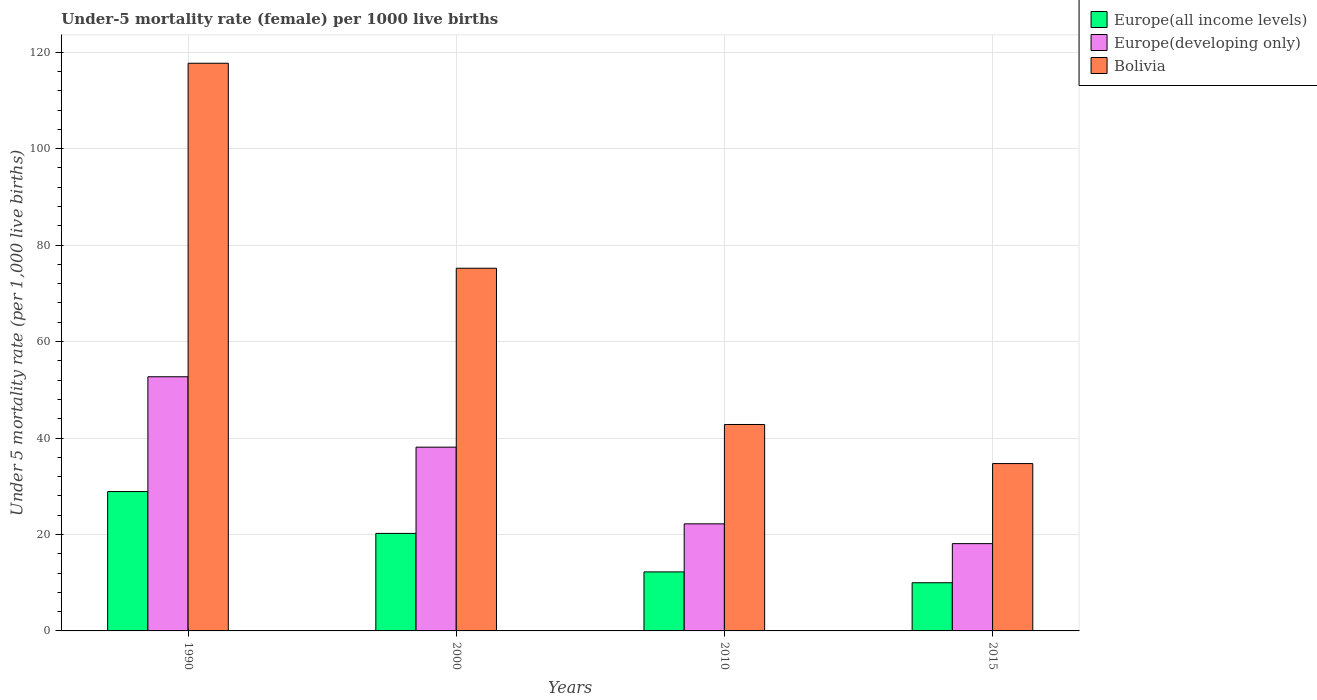How many different coloured bars are there?
Make the answer very short. 3. How many groups of bars are there?
Your answer should be compact. 4. Are the number of bars per tick equal to the number of legend labels?
Your answer should be compact. Yes. Are the number of bars on each tick of the X-axis equal?
Make the answer very short. Yes. What is the label of the 4th group of bars from the left?
Offer a terse response. 2015. What is the under-five mortality rate in Bolivia in 2015?
Provide a succinct answer. 34.7. Across all years, what is the maximum under-five mortality rate in Europe(all income levels)?
Your answer should be very brief. 28.9. Across all years, what is the minimum under-five mortality rate in Europe(developing only)?
Provide a succinct answer. 18.1. In which year was the under-five mortality rate in Europe(all income levels) minimum?
Your answer should be very brief. 2015. What is the total under-five mortality rate in Europe(developing only) in the graph?
Keep it short and to the point. 131.1. What is the difference between the under-five mortality rate in Europe(all income levels) in 2010 and that in 2015?
Offer a very short reply. 2.25. What is the difference between the under-five mortality rate in Europe(all income levels) in 2015 and the under-five mortality rate in Bolivia in 1990?
Offer a terse response. -107.71. What is the average under-five mortality rate in Europe(all income levels) per year?
Give a very brief answer. 17.84. In the year 2000, what is the difference between the under-five mortality rate in Europe(developing only) and under-five mortality rate in Europe(all income levels)?
Give a very brief answer. 17.88. What is the ratio of the under-five mortality rate in Europe(developing only) in 1990 to that in 2015?
Keep it short and to the point. 2.91. Is the under-five mortality rate in Europe(developing only) in 2000 less than that in 2015?
Offer a very short reply. No. What is the difference between the highest and the second highest under-five mortality rate in Europe(all income levels)?
Provide a succinct answer. 8.68. What is the difference between the highest and the lowest under-five mortality rate in Europe(all income levels)?
Your response must be concise. 18.9. Is the sum of the under-five mortality rate in Bolivia in 1990 and 2010 greater than the maximum under-five mortality rate in Europe(all income levels) across all years?
Offer a very short reply. Yes. What does the 1st bar from the left in 2015 represents?
Offer a terse response. Europe(all income levels). What does the 1st bar from the right in 2010 represents?
Keep it short and to the point. Bolivia. How many bars are there?
Provide a succinct answer. 12. How many years are there in the graph?
Ensure brevity in your answer.  4. What is the difference between two consecutive major ticks on the Y-axis?
Provide a short and direct response. 20. Are the values on the major ticks of Y-axis written in scientific E-notation?
Provide a succinct answer. No. Does the graph contain any zero values?
Offer a terse response. No. Where does the legend appear in the graph?
Give a very brief answer. Top right. How many legend labels are there?
Keep it short and to the point. 3. How are the legend labels stacked?
Make the answer very short. Vertical. What is the title of the graph?
Provide a succinct answer. Under-5 mortality rate (female) per 1000 live births. Does "Madagascar" appear as one of the legend labels in the graph?
Your answer should be compact. No. What is the label or title of the X-axis?
Your answer should be compact. Years. What is the label or title of the Y-axis?
Offer a very short reply. Under 5 mortality rate (per 1,0 live births). What is the Under 5 mortality rate (per 1,000 live births) of Europe(all income levels) in 1990?
Provide a short and direct response. 28.9. What is the Under 5 mortality rate (per 1,000 live births) of Europe(developing only) in 1990?
Offer a very short reply. 52.7. What is the Under 5 mortality rate (per 1,000 live births) in Bolivia in 1990?
Your answer should be compact. 117.7. What is the Under 5 mortality rate (per 1,000 live births) of Europe(all income levels) in 2000?
Give a very brief answer. 20.22. What is the Under 5 mortality rate (per 1,000 live births) in Europe(developing only) in 2000?
Ensure brevity in your answer.  38.1. What is the Under 5 mortality rate (per 1,000 live births) of Bolivia in 2000?
Ensure brevity in your answer.  75.2. What is the Under 5 mortality rate (per 1,000 live births) of Europe(all income levels) in 2010?
Make the answer very short. 12.24. What is the Under 5 mortality rate (per 1,000 live births) in Bolivia in 2010?
Your answer should be very brief. 42.8. What is the Under 5 mortality rate (per 1,000 live births) in Europe(all income levels) in 2015?
Provide a succinct answer. 9.99. What is the Under 5 mortality rate (per 1,000 live births) in Europe(developing only) in 2015?
Provide a succinct answer. 18.1. What is the Under 5 mortality rate (per 1,000 live births) in Bolivia in 2015?
Your response must be concise. 34.7. Across all years, what is the maximum Under 5 mortality rate (per 1,000 live births) of Europe(all income levels)?
Offer a very short reply. 28.9. Across all years, what is the maximum Under 5 mortality rate (per 1,000 live births) of Europe(developing only)?
Offer a terse response. 52.7. Across all years, what is the maximum Under 5 mortality rate (per 1,000 live births) in Bolivia?
Offer a very short reply. 117.7. Across all years, what is the minimum Under 5 mortality rate (per 1,000 live births) of Europe(all income levels)?
Ensure brevity in your answer.  9.99. Across all years, what is the minimum Under 5 mortality rate (per 1,000 live births) in Europe(developing only)?
Keep it short and to the point. 18.1. Across all years, what is the minimum Under 5 mortality rate (per 1,000 live births) of Bolivia?
Give a very brief answer. 34.7. What is the total Under 5 mortality rate (per 1,000 live births) of Europe(all income levels) in the graph?
Your answer should be compact. 71.34. What is the total Under 5 mortality rate (per 1,000 live births) of Europe(developing only) in the graph?
Provide a succinct answer. 131.1. What is the total Under 5 mortality rate (per 1,000 live births) in Bolivia in the graph?
Ensure brevity in your answer.  270.4. What is the difference between the Under 5 mortality rate (per 1,000 live births) of Europe(all income levels) in 1990 and that in 2000?
Provide a succinct answer. 8.68. What is the difference between the Under 5 mortality rate (per 1,000 live births) in Bolivia in 1990 and that in 2000?
Offer a terse response. 42.5. What is the difference between the Under 5 mortality rate (per 1,000 live births) in Europe(all income levels) in 1990 and that in 2010?
Keep it short and to the point. 16.66. What is the difference between the Under 5 mortality rate (per 1,000 live births) of Europe(developing only) in 1990 and that in 2010?
Keep it short and to the point. 30.5. What is the difference between the Under 5 mortality rate (per 1,000 live births) of Bolivia in 1990 and that in 2010?
Give a very brief answer. 74.9. What is the difference between the Under 5 mortality rate (per 1,000 live births) in Europe(all income levels) in 1990 and that in 2015?
Your response must be concise. 18.9. What is the difference between the Under 5 mortality rate (per 1,000 live births) of Europe(developing only) in 1990 and that in 2015?
Offer a terse response. 34.6. What is the difference between the Under 5 mortality rate (per 1,000 live births) of Europe(all income levels) in 2000 and that in 2010?
Make the answer very short. 7.98. What is the difference between the Under 5 mortality rate (per 1,000 live births) of Europe(developing only) in 2000 and that in 2010?
Your answer should be compact. 15.9. What is the difference between the Under 5 mortality rate (per 1,000 live births) in Bolivia in 2000 and that in 2010?
Ensure brevity in your answer.  32.4. What is the difference between the Under 5 mortality rate (per 1,000 live births) of Europe(all income levels) in 2000 and that in 2015?
Offer a terse response. 10.23. What is the difference between the Under 5 mortality rate (per 1,000 live births) in Bolivia in 2000 and that in 2015?
Offer a very short reply. 40.5. What is the difference between the Under 5 mortality rate (per 1,000 live births) in Europe(all income levels) in 2010 and that in 2015?
Your answer should be very brief. 2.25. What is the difference between the Under 5 mortality rate (per 1,000 live births) in Bolivia in 2010 and that in 2015?
Give a very brief answer. 8.1. What is the difference between the Under 5 mortality rate (per 1,000 live births) of Europe(all income levels) in 1990 and the Under 5 mortality rate (per 1,000 live births) of Europe(developing only) in 2000?
Your answer should be very brief. -9.2. What is the difference between the Under 5 mortality rate (per 1,000 live births) of Europe(all income levels) in 1990 and the Under 5 mortality rate (per 1,000 live births) of Bolivia in 2000?
Offer a terse response. -46.3. What is the difference between the Under 5 mortality rate (per 1,000 live births) in Europe(developing only) in 1990 and the Under 5 mortality rate (per 1,000 live births) in Bolivia in 2000?
Make the answer very short. -22.5. What is the difference between the Under 5 mortality rate (per 1,000 live births) of Europe(all income levels) in 1990 and the Under 5 mortality rate (per 1,000 live births) of Europe(developing only) in 2010?
Ensure brevity in your answer.  6.7. What is the difference between the Under 5 mortality rate (per 1,000 live births) in Europe(all income levels) in 1990 and the Under 5 mortality rate (per 1,000 live births) in Bolivia in 2010?
Ensure brevity in your answer.  -13.9. What is the difference between the Under 5 mortality rate (per 1,000 live births) of Europe(all income levels) in 1990 and the Under 5 mortality rate (per 1,000 live births) of Europe(developing only) in 2015?
Make the answer very short. 10.8. What is the difference between the Under 5 mortality rate (per 1,000 live births) in Europe(all income levels) in 1990 and the Under 5 mortality rate (per 1,000 live births) in Bolivia in 2015?
Offer a very short reply. -5.8. What is the difference between the Under 5 mortality rate (per 1,000 live births) of Europe(all income levels) in 2000 and the Under 5 mortality rate (per 1,000 live births) of Europe(developing only) in 2010?
Offer a very short reply. -1.98. What is the difference between the Under 5 mortality rate (per 1,000 live births) of Europe(all income levels) in 2000 and the Under 5 mortality rate (per 1,000 live births) of Bolivia in 2010?
Offer a terse response. -22.58. What is the difference between the Under 5 mortality rate (per 1,000 live births) in Europe(all income levels) in 2000 and the Under 5 mortality rate (per 1,000 live births) in Europe(developing only) in 2015?
Offer a very short reply. 2.12. What is the difference between the Under 5 mortality rate (per 1,000 live births) in Europe(all income levels) in 2000 and the Under 5 mortality rate (per 1,000 live births) in Bolivia in 2015?
Provide a succinct answer. -14.48. What is the difference between the Under 5 mortality rate (per 1,000 live births) of Europe(all income levels) in 2010 and the Under 5 mortality rate (per 1,000 live births) of Europe(developing only) in 2015?
Your response must be concise. -5.86. What is the difference between the Under 5 mortality rate (per 1,000 live births) of Europe(all income levels) in 2010 and the Under 5 mortality rate (per 1,000 live births) of Bolivia in 2015?
Provide a succinct answer. -22.46. What is the average Under 5 mortality rate (per 1,000 live births) of Europe(all income levels) per year?
Offer a terse response. 17.84. What is the average Under 5 mortality rate (per 1,000 live births) of Europe(developing only) per year?
Provide a succinct answer. 32.77. What is the average Under 5 mortality rate (per 1,000 live births) in Bolivia per year?
Offer a very short reply. 67.6. In the year 1990, what is the difference between the Under 5 mortality rate (per 1,000 live births) in Europe(all income levels) and Under 5 mortality rate (per 1,000 live births) in Europe(developing only)?
Keep it short and to the point. -23.8. In the year 1990, what is the difference between the Under 5 mortality rate (per 1,000 live births) of Europe(all income levels) and Under 5 mortality rate (per 1,000 live births) of Bolivia?
Give a very brief answer. -88.8. In the year 1990, what is the difference between the Under 5 mortality rate (per 1,000 live births) in Europe(developing only) and Under 5 mortality rate (per 1,000 live births) in Bolivia?
Provide a short and direct response. -65. In the year 2000, what is the difference between the Under 5 mortality rate (per 1,000 live births) of Europe(all income levels) and Under 5 mortality rate (per 1,000 live births) of Europe(developing only)?
Your response must be concise. -17.88. In the year 2000, what is the difference between the Under 5 mortality rate (per 1,000 live births) in Europe(all income levels) and Under 5 mortality rate (per 1,000 live births) in Bolivia?
Provide a succinct answer. -54.98. In the year 2000, what is the difference between the Under 5 mortality rate (per 1,000 live births) in Europe(developing only) and Under 5 mortality rate (per 1,000 live births) in Bolivia?
Keep it short and to the point. -37.1. In the year 2010, what is the difference between the Under 5 mortality rate (per 1,000 live births) of Europe(all income levels) and Under 5 mortality rate (per 1,000 live births) of Europe(developing only)?
Your answer should be compact. -9.96. In the year 2010, what is the difference between the Under 5 mortality rate (per 1,000 live births) in Europe(all income levels) and Under 5 mortality rate (per 1,000 live births) in Bolivia?
Provide a succinct answer. -30.56. In the year 2010, what is the difference between the Under 5 mortality rate (per 1,000 live births) in Europe(developing only) and Under 5 mortality rate (per 1,000 live births) in Bolivia?
Your answer should be compact. -20.6. In the year 2015, what is the difference between the Under 5 mortality rate (per 1,000 live births) of Europe(all income levels) and Under 5 mortality rate (per 1,000 live births) of Europe(developing only)?
Offer a very short reply. -8.11. In the year 2015, what is the difference between the Under 5 mortality rate (per 1,000 live births) in Europe(all income levels) and Under 5 mortality rate (per 1,000 live births) in Bolivia?
Keep it short and to the point. -24.71. In the year 2015, what is the difference between the Under 5 mortality rate (per 1,000 live births) of Europe(developing only) and Under 5 mortality rate (per 1,000 live births) of Bolivia?
Provide a short and direct response. -16.6. What is the ratio of the Under 5 mortality rate (per 1,000 live births) of Europe(all income levels) in 1990 to that in 2000?
Your answer should be compact. 1.43. What is the ratio of the Under 5 mortality rate (per 1,000 live births) of Europe(developing only) in 1990 to that in 2000?
Keep it short and to the point. 1.38. What is the ratio of the Under 5 mortality rate (per 1,000 live births) of Bolivia in 1990 to that in 2000?
Ensure brevity in your answer.  1.57. What is the ratio of the Under 5 mortality rate (per 1,000 live births) in Europe(all income levels) in 1990 to that in 2010?
Ensure brevity in your answer.  2.36. What is the ratio of the Under 5 mortality rate (per 1,000 live births) of Europe(developing only) in 1990 to that in 2010?
Provide a succinct answer. 2.37. What is the ratio of the Under 5 mortality rate (per 1,000 live births) of Bolivia in 1990 to that in 2010?
Ensure brevity in your answer.  2.75. What is the ratio of the Under 5 mortality rate (per 1,000 live births) of Europe(all income levels) in 1990 to that in 2015?
Offer a terse response. 2.89. What is the ratio of the Under 5 mortality rate (per 1,000 live births) in Europe(developing only) in 1990 to that in 2015?
Ensure brevity in your answer.  2.91. What is the ratio of the Under 5 mortality rate (per 1,000 live births) in Bolivia in 1990 to that in 2015?
Your answer should be compact. 3.39. What is the ratio of the Under 5 mortality rate (per 1,000 live births) in Europe(all income levels) in 2000 to that in 2010?
Ensure brevity in your answer.  1.65. What is the ratio of the Under 5 mortality rate (per 1,000 live births) in Europe(developing only) in 2000 to that in 2010?
Your answer should be compact. 1.72. What is the ratio of the Under 5 mortality rate (per 1,000 live births) in Bolivia in 2000 to that in 2010?
Your answer should be very brief. 1.76. What is the ratio of the Under 5 mortality rate (per 1,000 live births) of Europe(all income levels) in 2000 to that in 2015?
Provide a succinct answer. 2.02. What is the ratio of the Under 5 mortality rate (per 1,000 live births) in Europe(developing only) in 2000 to that in 2015?
Give a very brief answer. 2.1. What is the ratio of the Under 5 mortality rate (per 1,000 live births) in Bolivia in 2000 to that in 2015?
Provide a succinct answer. 2.17. What is the ratio of the Under 5 mortality rate (per 1,000 live births) in Europe(all income levels) in 2010 to that in 2015?
Offer a very short reply. 1.22. What is the ratio of the Under 5 mortality rate (per 1,000 live births) in Europe(developing only) in 2010 to that in 2015?
Offer a very short reply. 1.23. What is the ratio of the Under 5 mortality rate (per 1,000 live births) in Bolivia in 2010 to that in 2015?
Offer a terse response. 1.23. What is the difference between the highest and the second highest Under 5 mortality rate (per 1,000 live births) of Europe(all income levels)?
Your answer should be very brief. 8.68. What is the difference between the highest and the second highest Under 5 mortality rate (per 1,000 live births) of Bolivia?
Provide a short and direct response. 42.5. What is the difference between the highest and the lowest Under 5 mortality rate (per 1,000 live births) in Europe(all income levels)?
Ensure brevity in your answer.  18.9. What is the difference between the highest and the lowest Under 5 mortality rate (per 1,000 live births) in Europe(developing only)?
Keep it short and to the point. 34.6. What is the difference between the highest and the lowest Under 5 mortality rate (per 1,000 live births) of Bolivia?
Your response must be concise. 83. 